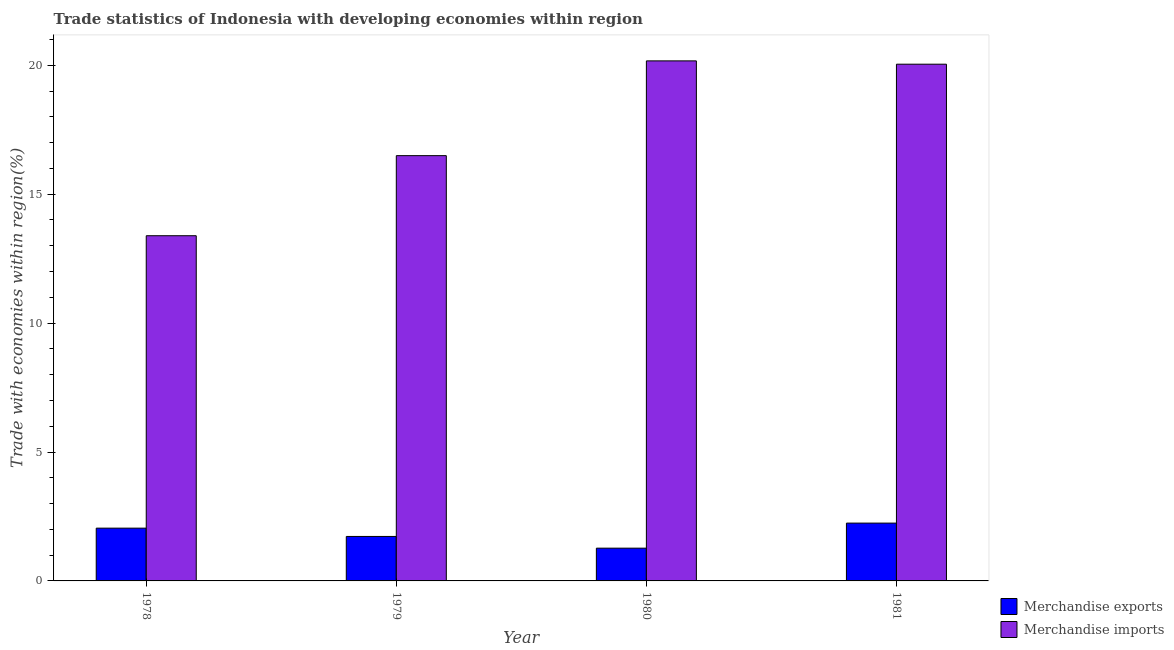Are the number of bars on each tick of the X-axis equal?
Offer a terse response. Yes. How many bars are there on the 1st tick from the left?
Provide a short and direct response. 2. How many bars are there on the 4th tick from the right?
Ensure brevity in your answer.  2. What is the label of the 2nd group of bars from the left?
Provide a short and direct response. 1979. What is the merchandise imports in 1980?
Offer a very short reply. 20.17. Across all years, what is the maximum merchandise exports?
Offer a terse response. 2.24. Across all years, what is the minimum merchandise imports?
Offer a very short reply. 13.39. In which year was the merchandise imports maximum?
Make the answer very short. 1980. In which year was the merchandise imports minimum?
Make the answer very short. 1978. What is the total merchandise imports in the graph?
Keep it short and to the point. 70.1. What is the difference between the merchandise exports in 1979 and that in 1981?
Your response must be concise. -0.52. What is the difference between the merchandise exports in 1981 and the merchandise imports in 1980?
Ensure brevity in your answer.  0.97. What is the average merchandise imports per year?
Your answer should be compact. 17.52. In how many years, is the merchandise imports greater than 5 %?
Ensure brevity in your answer.  4. What is the ratio of the merchandise exports in 1980 to that in 1981?
Provide a short and direct response. 0.57. What is the difference between the highest and the second highest merchandise imports?
Provide a succinct answer. 0.13. What is the difference between the highest and the lowest merchandise imports?
Ensure brevity in your answer.  6.78. In how many years, is the merchandise imports greater than the average merchandise imports taken over all years?
Your answer should be very brief. 2. Is the sum of the merchandise exports in 1978 and 1981 greater than the maximum merchandise imports across all years?
Ensure brevity in your answer.  Yes. What does the 1st bar from the right in 1978 represents?
Provide a short and direct response. Merchandise imports. How many bars are there?
Offer a very short reply. 8. Are all the bars in the graph horizontal?
Give a very brief answer. No. What is the difference between two consecutive major ticks on the Y-axis?
Make the answer very short. 5. Are the values on the major ticks of Y-axis written in scientific E-notation?
Your answer should be compact. No. Does the graph contain any zero values?
Offer a very short reply. No. How are the legend labels stacked?
Your answer should be very brief. Vertical. What is the title of the graph?
Offer a terse response. Trade statistics of Indonesia with developing economies within region. What is the label or title of the X-axis?
Your answer should be compact. Year. What is the label or title of the Y-axis?
Keep it short and to the point. Trade with economies within region(%). What is the Trade with economies within region(%) in Merchandise exports in 1978?
Give a very brief answer. 2.05. What is the Trade with economies within region(%) in Merchandise imports in 1978?
Give a very brief answer. 13.39. What is the Trade with economies within region(%) in Merchandise exports in 1979?
Give a very brief answer. 1.72. What is the Trade with economies within region(%) in Merchandise imports in 1979?
Your response must be concise. 16.5. What is the Trade with economies within region(%) of Merchandise exports in 1980?
Provide a short and direct response. 1.27. What is the Trade with economies within region(%) in Merchandise imports in 1980?
Ensure brevity in your answer.  20.17. What is the Trade with economies within region(%) of Merchandise exports in 1981?
Your answer should be very brief. 2.24. What is the Trade with economies within region(%) in Merchandise imports in 1981?
Make the answer very short. 20.04. Across all years, what is the maximum Trade with economies within region(%) in Merchandise exports?
Ensure brevity in your answer.  2.24. Across all years, what is the maximum Trade with economies within region(%) of Merchandise imports?
Provide a succinct answer. 20.17. Across all years, what is the minimum Trade with economies within region(%) in Merchandise exports?
Provide a succinct answer. 1.27. Across all years, what is the minimum Trade with economies within region(%) in Merchandise imports?
Provide a short and direct response. 13.39. What is the total Trade with economies within region(%) of Merchandise exports in the graph?
Offer a very short reply. 7.29. What is the total Trade with economies within region(%) of Merchandise imports in the graph?
Your answer should be very brief. 70.1. What is the difference between the Trade with economies within region(%) in Merchandise exports in 1978 and that in 1979?
Keep it short and to the point. 0.32. What is the difference between the Trade with economies within region(%) of Merchandise imports in 1978 and that in 1979?
Keep it short and to the point. -3.11. What is the difference between the Trade with economies within region(%) in Merchandise exports in 1978 and that in 1980?
Offer a terse response. 0.78. What is the difference between the Trade with economies within region(%) in Merchandise imports in 1978 and that in 1980?
Your response must be concise. -6.78. What is the difference between the Trade with economies within region(%) of Merchandise exports in 1978 and that in 1981?
Provide a short and direct response. -0.2. What is the difference between the Trade with economies within region(%) in Merchandise imports in 1978 and that in 1981?
Keep it short and to the point. -6.65. What is the difference between the Trade with economies within region(%) in Merchandise exports in 1979 and that in 1980?
Provide a short and direct response. 0.45. What is the difference between the Trade with economies within region(%) in Merchandise imports in 1979 and that in 1980?
Offer a very short reply. -3.68. What is the difference between the Trade with economies within region(%) of Merchandise exports in 1979 and that in 1981?
Provide a succinct answer. -0.52. What is the difference between the Trade with economies within region(%) of Merchandise imports in 1979 and that in 1981?
Offer a very short reply. -3.55. What is the difference between the Trade with economies within region(%) in Merchandise exports in 1980 and that in 1981?
Ensure brevity in your answer.  -0.97. What is the difference between the Trade with economies within region(%) in Merchandise imports in 1980 and that in 1981?
Offer a terse response. 0.13. What is the difference between the Trade with economies within region(%) in Merchandise exports in 1978 and the Trade with economies within region(%) in Merchandise imports in 1979?
Make the answer very short. -14.45. What is the difference between the Trade with economies within region(%) in Merchandise exports in 1978 and the Trade with economies within region(%) in Merchandise imports in 1980?
Give a very brief answer. -18.12. What is the difference between the Trade with economies within region(%) of Merchandise exports in 1978 and the Trade with economies within region(%) of Merchandise imports in 1981?
Make the answer very short. -18. What is the difference between the Trade with economies within region(%) of Merchandise exports in 1979 and the Trade with economies within region(%) of Merchandise imports in 1980?
Ensure brevity in your answer.  -18.45. What is the difference between the Trade with economies within region(%) of Merchandise exports in 1979 and the Trade with economies within region(%) of Merchandise imports in 1981?
Give a very brief answer. -18.32. What is the difference between the Trade with economies within region(%) in Merchandise exports in 1980 and the Trade with economies within region(%) in Merchandise imports in 1981?
Keep it short and to the point. -18.77. What is the average Trade with economies within region(%) in Merchandise exports per year?
Ensure brevity in your answer.  1.82. What is the average Trade with economies within region(%) in Merchandise imports per year?
Offer a terse response. 17.52. In the year 1978, what is the difference between the Trade with economies within region(%) of Merchandise exports and Trade with economies within region(%) of Merchandise imports?
Give a very brief answer. -11.34. In the year 1979, what is the difference between the Trade with economies within region(%) of Merchandise exports and Trade with economies within region(%) of Merchandise imports?
Offer a terse response. -14.77. In the year 1980, what is the difference between the Trade with economies within region(%) of Merchandise exports and Trade with economies within region(%) of Merchandise imports?
Your response must be concise. -18.9. In the year 1981, what is the difference between the Trade with economies within region(%) of Merchandise exports and Trade with economies within region(%) of Merchandise imports?
Offer a very short reply. -17.8. What is the ratio of the Trade with economies within region(%) of Merchandise exports in 1978 to that in 1979?
Ensure brevity in your answer.  1.19. What is the ratio of the Trade with economies within region(%) of Merchandise imports in 1978 to that in 1979?
Keep it short and to the point. 0.81. What is the ratio of the Trade with economies within region(%) in Merchandise exports in 1978 to that in 1980?
Provide a succinct answer. 1.61. What is the ratio of the Trade with economies within region(%) of Merchandise imports in 1978 to that in 1980?
Give a very brief answer. 0.66. What is the ratio of the Trade with economies within region(%) of Merchandise exports in 1978 to that in 1981?
Offer a very short reply. 0.91. What is the ratio of the Trade with economies within region(%) in Merchandise imports in 1978 to that in 1981?
Your response must be concise. 0.67. What is the ratio of the Trade with economies within region(%) in Merchandise exports in 1979 to that in 1980?
Provide a short and direct response. 1.36. What is the ratio of the Trade with economies within region(%) in Merchandise imports in 1979 to that in 1980?
Your answer should be very brief. 0.82. What is the ratio of the Trade with economies within region(%) of Merchandise exports in 1979 to that in 1981?
Offer a terse response. 0.77. What is the ratio of the Trade with economies within region(%) in Merchandise imports in 1979 to that in 1981?
Your response must be concise. 0.82. What is the ratio of the Trade with economies within region(%) of Merchandise exports in 1980 to that in 1981?
Make the answer very short. 0.57. What is the ratio of the Trade with economies within region(%) of Merchandise imports in 1980 to that in 1981?
Give a very brief answer. 1.01. What is the difference between the highest and the second highest Trade with economies within region(%) in Merchandise exports?
Give a very brief answer. 0.2. What is the difference between the highest and the second highest Trade with economies within region(%) of Merchandise imports?
Your response must be concise. 0.13. What is the difference between the highest and the lowest Trade with economies within region(%) in Merchandise exports?
Keep it short and to the point. 0.97. What is the difference between the highest and the lowest Trade with economies within region(%) of Merchandise imports?
Your response must be concise. 6.78. 